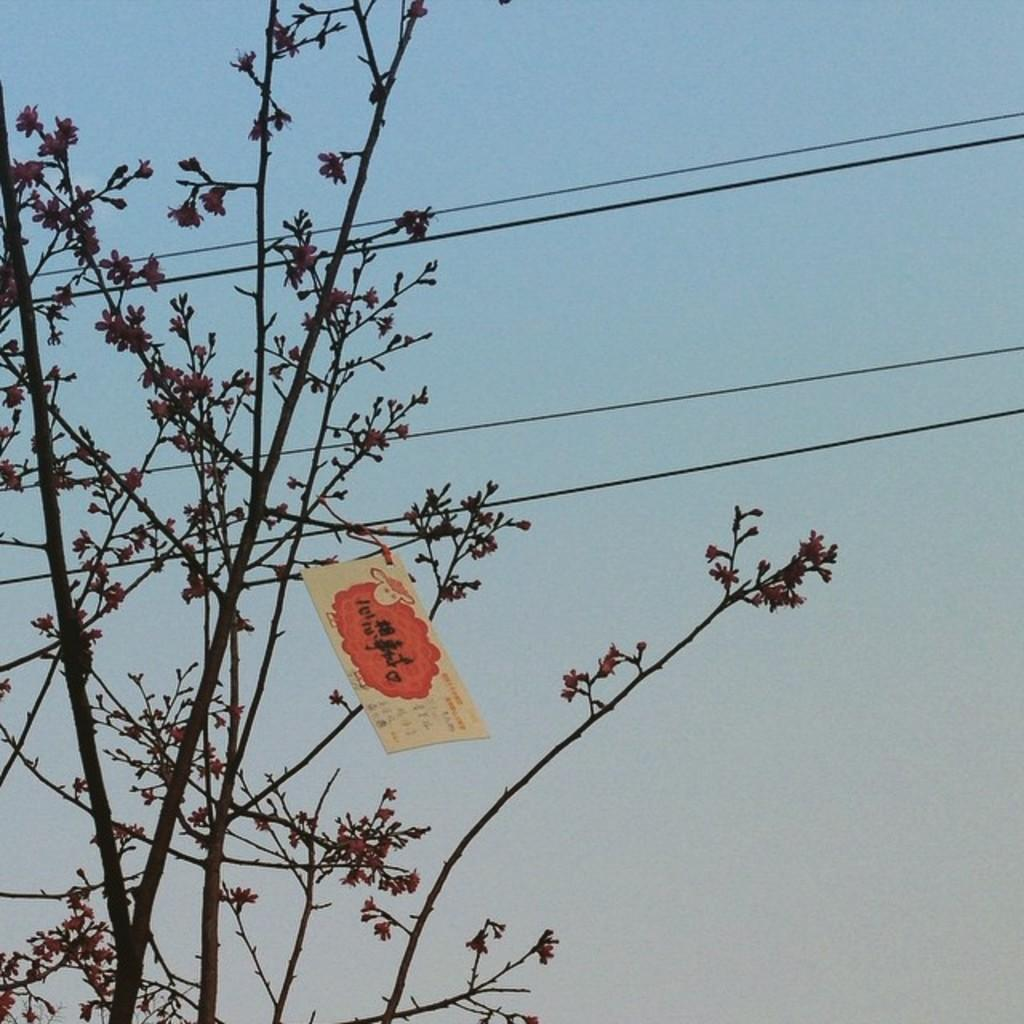What type of vegetation can be seen in the image? There are trees in the image. What else can be seen in the image besides trees? There are wires and a poster visible in the image. What is visible in the background of the image? The sky is visible in the image. What scent can be detected from the trees in the image? There is no information about the scent of the trees in the image, as we cannot smell through a picture. 